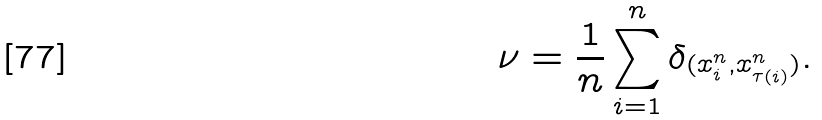Convert formula to latex. <formula><loc_0><loc_0><loc_500><loc_500>\nu = \frac { 1 } { n } \sum _ { i = 1 } ^ { n } \delta _ { ( x _ { i } ^ { n } , x _ { \tau ( i ) } ^ { n } ) } .</formula> 